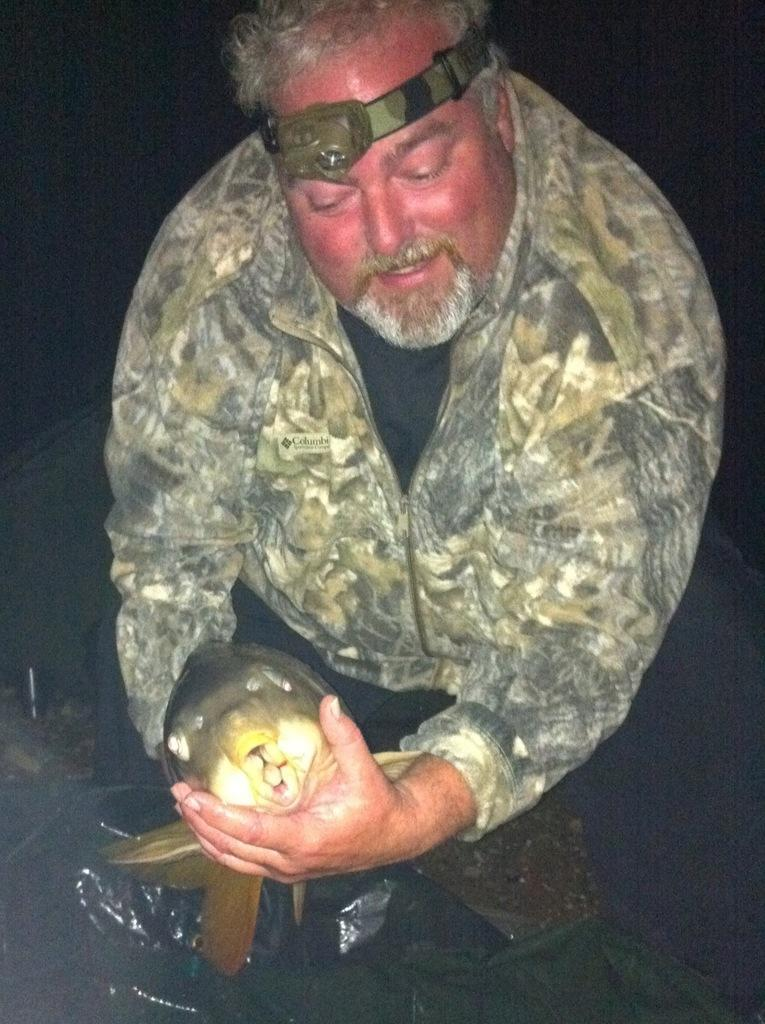Who is the main subject in the image? There is a man in the image. What is the man wearing? The man is wearing a jacket. What is the man doing in the image? The man is sitting. How would you describe the lighting in the image? The image is dark. What type of flowers can be seen in the front of the image? There are no flowers present in the image. Can you describe the bird that is flying in the background of the image? There is no bird present in the image. 